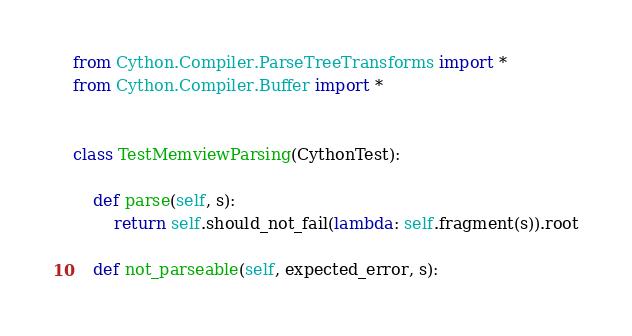<code> <loc_0><loc_0><loc_500><loc_500><_Python_>from Cython.Compiler.ParseTreeTransforms import *
from Cython.Compiler.Buffer import *


class TestMemviewParsing(CythonTest):

    def parse(self, s):
        return self.should_not_fail(lambda: self.fragment(s)).root

    def not_parseable(self, expected_error, s):</code> 